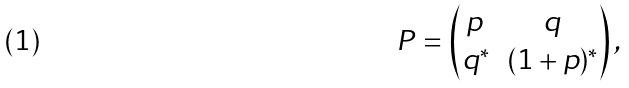Convert formula to latex. <formula><loc_0><loc_0><loc_500><loc_500>P = \begin{pmatrix} p \, & q \\ q ^ { \ast } & ( 1 + p ) ^ { \ast } \end{pmatrix} ,</formula> 